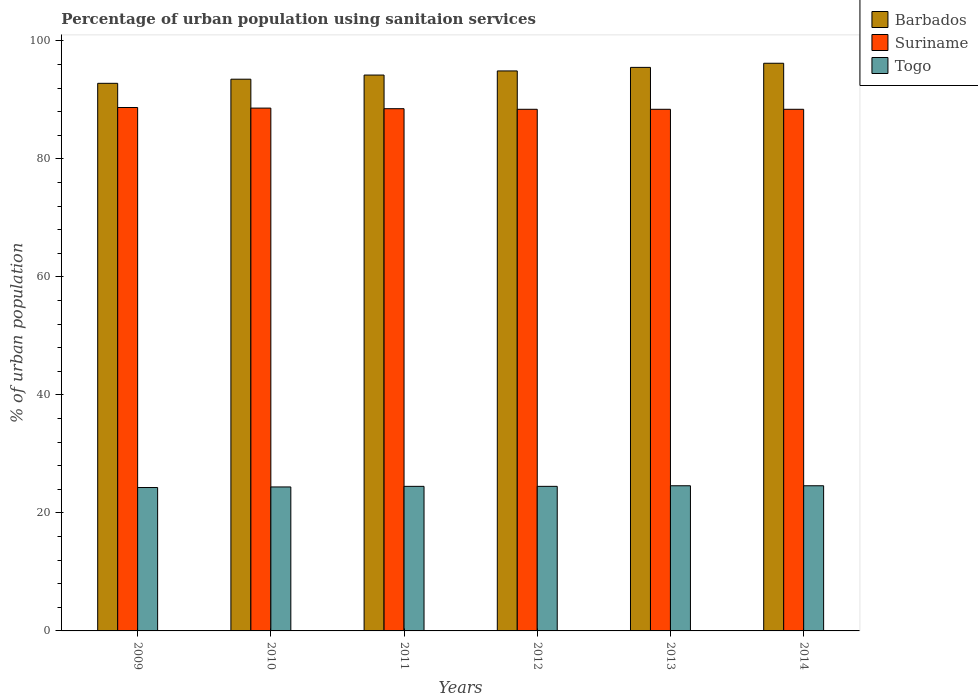How many different coloured bars are there?
Keep it short and to the point. 3. Are the number of bars per tick equal to the number of legend labels?
Give a very brief answer. Yes. In how many cases, is the number of bars for a given year not equal to the number of legend labels?
Offer a very short reply. 0. What is the percentage of urban population using sanitaion services in Barbados in 2010?
Keep it short and to the point. 93.5. Across all years, what is the maximum percentage of urban population using sanitaion services in Barbados?
Your answer should be compact. 96.2. Across all years, what is the minimum percentage of urban population using sanitaion services in Togo?
Your answer should be very brief. 24.3. In which year was the percentage of urban population using sanitaion services in Suriname minimum?
Keep it short and to the point. 2012. What is the total percentage of urban population using sanitaion services in Togo in the graph?
Give a very brief answer. 146.9. What is the difference between the percentage of urban population using sanitaion services in Suriname in 2009 and that in 2014?
Your answer should be compact. 0.3. What is the difference between the percentage of urban population using sanitaion services in Suriname in 2011 and the percentage of urban population using sanitaion services in Togo in 2013?
Give a very brief answer. 63.9. What is the average percentage of urban population using sanitaion services in Togo per year?
Ensure brevity in your answer.  24.48. In the year 2014, what is the difference between the percentage of urban population using sanitaion services in Barbados and percentage of urban population using sanitaion services in Suriname?
Ensure brevity in your answer.  7.8. In how many years, is the percentage of urban population using sanitaion services in Barbados greater than 20 %?
Offer a very short reply. 6. What is the ratio of the percentage of urban population using sanitaion services in Barbados in 2009 to that in 2013?
Make the answer very short. 0.97. What is the difference between the highest and the second highest percentage of urban population using sanitaion services in Suriname?
Keep it short and to the point. 0.1. What is the difference between the highest and the lowest percentage of urban population using sanitaion services in Barbados?
Offer a terse response. 3.4. In how many years, is the percentage of urban population using sanitaion services in Barbados greater than the average percentage of urban population using sanitaion services in Barbados taken over all years?
Offer a terse response. 3. What does the 3rd bar from the left in 2013 represents?
Keep it short and to the point. Togo. What does the 3rd bar from the right in 2012 represents?
Keep it short and to the point. Barbados. Is it the case that in every year, the sum of the percentage of urban population using sanitaion services in Togo and percentage of urban population using sanitaion services in Suriname is greater than the percentage of urban population using sanitaion services in Barbados?
Your answer should be very brief. Yes. Are all the bars in the graph horizontal?
Keep it short and to the point. No. How many years are there in the graph?
Your answer should be very brief. 6. What is the difference between two consecutive major ticks on the Y-axis?
Provide a short and direct response. 20. Are the values on the major ticks of Y-axis written in scientific E-notation?
Your response must be concise. No. Does the graph contain grids?
Provide a short and direct response. No. How many legend labels are there?
Keep it short and to the point. 3. What is the title of the graph?
Ensure brevity in your answer.  Percentage of urban population using sanitaion services. Does "Paraguay" appear as one of the legend labels in the graph?
Ensure brevity in your answer.  No. What is the label or title of the Y-axis?
Provide a succinct answer. % of urban population. What is the % of urban population in Barbados in 2009?
Offer a very short reply. 92.8. What is the % of urban population in Suriname in 2009?
Give a very brief answer. 88.7. What is the % of urban population of Togo in 2009?
Ensure brevity in your answer.  24.3. What is the % of urban population in Barbados in 2010?
Ensure brevity in your answer.  93.5. What is the % of urban population of Suriname in 2010?
Provide a succinct answer. 88.6. What is the % of urban population in Togo in 2010?
Provide a short and direct response. 24.4. What is the % of urban population of Barbados in 2011?
Offer a terse response. 94.2. What is the % of urban population in Suriname in 2011?
Provide a succinct answer. 88.5. What is the % of urban population in Togo in 2011?
Provide a succinct answer. 24.5. What is the % of urban population in Barbados in 2012?
Offer a very short reply. 94.9. What is the % of urban population in Suriname in 2012?
Make the answer very short. 88.4. What is the % of urban population of Barbados in 2013?
Give a very brief answer. 95.5. What is the % of urban population in Suriname in 2013?
Your answer should be compact. 88.4. What is the % of urban population in Togo in 2013?
Provide a succinct answer. 24.6. What is the % of urban population in Barbados in 2014?
Provide a short and direct response. 96.2. What is the % of urban population in Suriname in 2014?
Ensure brevity in your answer.  88.4. What is the % of urban population in Togo in 2014?
Make the answer very short. 24.6. Across all years, what is the maximum % of urban population in Barbados?
Keep it short and to the point. 96.2. Across all years, what is the maximum % of urban population in Suriname?
Provide a succinct answer. 88.7. Across all years, what is the maximum % of urban population in Togo?
Ensure brevity in your answer.  24.6. Across all years, what is the minimum % of urban population of Barbados?
Offer a terse response. 92.8. Across all years, what is the minimum % of urban population of Suriname?
Keep it short and to the point. 88.4. Across all years, what is the minimum % of urban population of Togo?
Provide a short and direct response. 24.3. What is the total % of urban population of Barbados in the graph?
Ensure brevity in your answer.  567.1. What is the total % of urban population of Suriname in the graph?
Your response must be concise. 531. What is the total % of urban population in Togo in the graph?
Keep it short and to the point. 146.9. What is the difference between the % of urban population in Barbados in 2009 and that in 2010?
Your response must be concise. -0.7. What is the difference between the % of urban population in Suriname in 2009 and that in 2010?
Your answer should be compact. 0.1. What is the difference between the % of urban population of Suriname in 2009 and that in 2011?
Provide a short and direct response. 0.2. What is the difference between the % of urban population in Barbados in 2009 and that in 2012?
Keep it short and to the point. -2.1. What is the difference between the % of urban population in Togo in 2009 and that in 2012?
Your answer should be very brief. -0.2. What is the difference between the % of urban population in Barbados in 2009 and that in 2013?
Keep it short and to the point. -2.7. What is the difference between the % of urban population of Suriname in 2009 and that in 2013?
Offer a very short reply. 0.3. What is the difference between the % of urban population of Togo in 2009 and that in 2013?
Offer a terse response. -0.3. What is the difference between the % of urban population in Barbados in 2009 and that in 2014?
Your response must be concise. -3.4. What is the difference between the % of urban population in Togo in 2009 and that in 2014?
Your answer should be compact. -0.3. What is the difference between the % of urban population in Barbados in 2010 and that in 2011?
Your answer should be compact. -0.7. What is the difference between the % of urban population in Togo in 2010 and that in 2011?
Ensure brevity in your answer.  -0.1. What is the difference between the % of urban population of Barbados in 2010 and that in 2012?
Offer a very short reply. -1.4. What is the difference between the % of urban population in Suriname in 2010 and that in 2012?
Give a very brief answer. 0.2. What is the difference between the % of urban population of Togo in 2010 and that in 2012?
Ensure brevity in your answer.  -0.1. What is the difference between the % of urban population of Barbados in 2010 and that in 2014?
Keep it short and to the point. -2.7. What is the difference between the % of urban population of Togo in 2010 and that in 2014?
Offer a terse response. -0.2. What is the difference between the % of urban population of Barbados in 2011 and that in 2012?
Offer a very short reply. -0.7. What is the difference between the % of urban population of Suriname in 2011 and that in 2012?
Provide a short and direct response. 0.1. What is the difference between the % of urban population in Suriname in 2011 and that in 2013?
Your answer should be compact. 0.1. What is the difference between the % of urban population of Suriname in 2011 and that in 2014?
Your answer should be very brief. 0.1. What is the difference between the % of urban population in Togo in 2011 and that in 2014?
Provide a short and direct response. -0.1. What is the difference between the % of urban population in Suriname in 2012 and that in 2013?
Provide a short and direct response. 0. What is the difference between the % of urban population of Barbados in 2009 and the % of urban population of Suriname in 2010?
Offer a very short reply. 4.2. What is the difference between the % of urban population of Barbados in 2009 and the % of urban population of Togo in 2010?
Provide a succinct answer. 68.4. What is the difference between the % of urban population in Suriname in 2009 and the % of urban population in Togo in 2010?
Provide a succinct answer. 64.3. What is the difference between the % of urban population in Barbados in 2009 and the % of urban population in Suriname in 2011?
Your answer should be compact. 4.3. What is the difference between the % of urban population in Barbados in 2009 and the % of urban population in Togo in 2011?
Give a very brief answer. 68.3. What is the difference between the % of urban population in Suriname in 2009 and the % of urban population in Togo in 2011?
Provide a succinct answer. 64.2. What is the difference between the % of urban population of Barbados in 2009 and the % of urban population of Suriname in 2012?
Keep it short and to the point. 4.4. What is the difference between the % of urban population of Barbados in 2009 and the % of urban population of Togo in 2012?
Give a very brief answer. 68.3. What is the difference between the % of urban population in Suriname in 2009 and the % of urban population in Togo in 2012?
Offer a terse response. 64.2. What is the difference between the % of urban population in Barbados in 2009 and the % of urban population in Suriname in 2013?
Your answer should be compact. 4.4. What is the difference between the % of urban population in Barbados in 2009 and the % of urban population in Togo in 2013?
Offer a very short reply. 68.2. What is the difference between the % of urban population of Suriname in 2009 and the % of urban population of Togo in 2013?
Provide a short and direct response. 64.1. What is the difference between the % of urban population of Barbados in 2009 and the % of urban population of Togo in 2014?
Provide a succinct answer. 68.2. What is the difference between the % of urban population in Suriname in 2009 and the % of urban population in Togo in 2014?
Offer a very short reply. 64.1. What is the difference between the % of urban population in Barbados in 2010 and the % of urban population in Suriname in 2011?
Give a very brief answer. 5. What is the difference between the % of urban population in Barbados in 2010 and the % of urban population in Togo in 2011?
Your answer should be very brief. 69. What is the difference between the % of urban population in Suriname in 2010 and the % of urban population in Togo in 2011?
Provide a short and direct response. 64.1. What is the difference between the % of urban population in Barbados in 2010 and the % of urban population in Suriname in 2012?
Offer a terse response. 5.1. What is the difference between the % of urban population of Barbados in 2010 and the % of urban population of Togo in 2012?
Give a very brief answer. 69. What is the difference between the % of urban population of Suriname in 2010 and the % of urban population of Togo in 2012?
Provide a short and direct response. 64.1. What is the difference between the % of urban population in Barbados in 2010 and the % of urban population in Togo in 2013?
Offer a very short reply. 68.9. What is the difference between the % of urban population in Barbados in 2010 and the % of urban population in Togo in 2014?
Your response must be concise. 68.9. What is the difference between the % of urban population of Suriname in 2010 and the % of urban population of Togo in 2014?
Provide a short and direct response. 64. What is the difference between the % of urban population of Barbados in 2011 and the % of urban population of Suriname in 2012?
Give a very brief answer. 5.8. What is the difference between the % of urban population in Barbados in 2011 and the % of urban population in Togo in 2012?
Keep it short and to the point. 69.7. What is the difference between the % of urban population of Suriname in 2011 and the % of urban population of Togo in 2012?
Your answer should be compact. 64. What is the difference between the % of urban population of Barbados in 2011 and the % of urban population of Suriname in 2013?
Your answer should be very brief. 5.8. What is the difference between the % of urban population in Barbados in 2011 and the % of urban population in Togo in 2013?
Provide a succinct answer. 69.6. What is the difference between the % of urban population of Suriname in 2011 and the % of urban population of Togo in 2013?
Provide a succinct answer. 63.9. What is the difference between the % of urban population in Barbados in 2011 and the % of urban population in Suriname in 2014?
Your response must be concise. 5.8. What is the difference between the % of urban population in Barbados in 2011 and the % of urban population in Togo in 2014?
Keep it short and to the point. 69.6. What is the difference between the % of urban population in Suriname in 2011 and the % of urban population in Togo in 2014?
Provide a short and direct response. 63.9. What is the difference between the % of urban population in Barbados in 2012 and the % of urban population in Togo in 2013?
Ensure brevity in your answer.  70.3. What is the difference between the % of urban population of Suriname in 2012 and the % of urban population of Togo in 2013?
Keep it short and to the point. 63.8. What is the difference between the % of urban population of Barbados in 2012 and the % of urban population of Suriname in 2014?
Give a very brief answer. 6.5. What is the difference between the % of urban population of Barbados in 2012 and the % of urban population of Togo in 2014?
Make the answer very short. 70.3. What is the difference between the % of urban population of Suriname in 2012 and the % of urban population of Togo in 2014?
Ensure brevity in your answer.  63.8. What is the difference between the % of urban population of Barbados in 2013 and the % of urban population of Suriname in 2014?
Your answer should be compact. 7.1. What is the difference between the % of urban population of Barbados in 2013 and the % of urban population of Togo in 2014?
Keep it short and to the point. 70.9. What is the difference between the % of urban population in Suriname in 2013 and the % of urban population in Togo in 2014?
Provide a succinct answer. 63.8. What is the average % of urban population in Barbados per year?
Offer a very short reply. 94.52. What is the average % of urban population in Suriname per year?
Make the answer very short. 88.5. What is the average % of urban population in Togo per year?
Offer a very short reply. 24.48. In the year 2009, what is the difference between the % of urban population of Barbados and % of urban population of Togo?
Your answer should be very brief. 68.5. In the year 2009, what is the difference between the % of urban population in Suriname and % of urban population in Togo?
Your response must be concise. 64.4. In the year 2010, what is the difference between the % of urban population in Barbados and % of urban population in Suriname?
Your answer should be compact. 4.9. In the year 2010, what is the difference between the % of urban population in Barbados and % of urban population in Togo?
Provide a succinct answer. 69.1. In the year 2010, what is the difference between the % of urban population in Suriname and % of urban population in Togo?
Provide a short and direct response. 64.2. In the year 2011, what is the difference between the % of urban population of Barbados and % of urban population of Suriname?
Your answer should be very brief. 5.7. In the year 2011, what is the difference between the % of urban population in Barbados and % of urban population in Togo?
Give a very brief answer. 69.7. In the year 2012, what is the difference between the % of urban population in Barbados and % of urban population in Togo?
Offer a terse response. 70.4. In the year 2012, what is the difference between the % of urban population of Suriname and % of urban population of Togo?
Provide a succinct answer. 63.9. In the year 2013, what is the difference between the % of urban population of Barbados and % of urban population of Suriname?
Your response must be concise. 7.1. In the year 2013, what is the difference between the % of urban population in Barbados and % of urban population in Togo?
Make the answer very short. 70.9. In the year 2013, what is the difference between the % of urban population of Suriname and % of urban population of Togo?
Your response must be concise. 63.8. In the year 2014, what is the difference between the % of urban population of Barbados and % of urban population of Togo?
Give a very brief answer. 71.6. In the year 2014, what is the difference between the % of urban population of Suriname and % of urban population of Togo?
Keep it short and to the point. 63.8. What is the ratio of the % of urban population in Suriname in 2009 to that in 2010?
Keep it short and to the point. 1. What is the ratio of the % of urban population of Togo in 2009 to that in 2010?
Your response must be concise. 1. What is the ratio of the % of urban population in Barbados in 2009 to that in 2011?
Ensure brevity in your answer.  0.99. What is the ratio of the % of urban population in Suriname in 2009 to that in 2011?
Your answer should be very brief. 1. What is the ratio of the % of urban population of Togo in 2009 to that in 2011?
Ensure brevity in your answer.  0.99. What is the ratio of the % of urban population of Barbados in 2009 to that in 2012?
Offer a terse response. 0.98. What is the ratio of the % of urban population of Suriname in 2009 to that in 2012?
Your response must be concise. 1. What is the ratio of the % of urban population of Barbados in 2009 to that in 2013?
Keep it short and to the point. 0.97. What is the ratio of the % of urban population in Suriname in 2009 to that in 2013?
Your response must be concise. 1. What is the ratio of the % of urban population of Barbados in 2009 to that in 2014?
Keep it short and to the point. 0.96. What is the ratio of the % of urban population in Suriname in 2009 to that in 2014?
Provide a succinct answer. 1. What is the ratio of the % of urban population in Barbados in 2010 to that in 2011?
Your response must be concise. 0.99. What is the ratio of the % of urban population of Suriname in 2010 to that in 2011?
Provide a short and direct response. 1. What is the ratio of the % of urban population of Togo in 2010 to that in 2011?
Your answer should be very brief. 1. What is the ratio of the % of urban population of Barbados in 2010 to that in 2012?
Your answer should be very brief. 0.99. What is the ratio of the % of urban population in Suriname in 2010 to that in 2012?
Make the answer very short. 1. What is the ratio of the % of urban population in Barbados in 2010 to that in 2013?
Provide a succinct answer. 0.98. What is the ratio of the % of urban population in Barbados in 2010 to that in 2014?
Make the answer very short. 0.97. What is the ratio of the % of urban population of Suriname in 2011 to that in 2012?
Provide a short and direct response. 1. What is the ratio of the % of urban population in Barbados in 2011 to that in 2013?
Offer a terse response. 0.99. What is the ratio of the % of urban population in Togo in 2011 to that in 2013?
Provide a succinct answer. 1. What is the ratio of the % of urban population of Barbados in 2011 to that in 2014?
Your answer should be compact. 0.98. What is the ratio of the % of urban population of Togo in 2012 to that in 2013?
Keep it short and to the point. 1. What is the ratio of the % of urban population of Barbados in 2012 to that in 2014?
Your answer should be compact. 0.99. What is the ratio of the % of urban population in Togo in 2012 to that in 2014?
Make the answer very short. 1. What is the ratio of the % of urban population of Barbados in 2013 to that in 2014?
Offer a very short reply. 0.99. What is the ratio of the % of urban population in Suriname in 2013 to that in 2014?
Offer a very short reply. 1. What is the difference between the highest and the second highest % of urban population of Suriname?
Your response must be concise. 0.1. What is the difference between the highest and the second highest % of urban population in Togo?
Your answer should be very brief. 0. What is the difference between the highest and the lowest % of urban population of Barbados?
Provide a succinct answer. 3.4. What is the difference between the highest and the lowest % of urban population of Togo?
Provide a succinct answer. 0.3. 